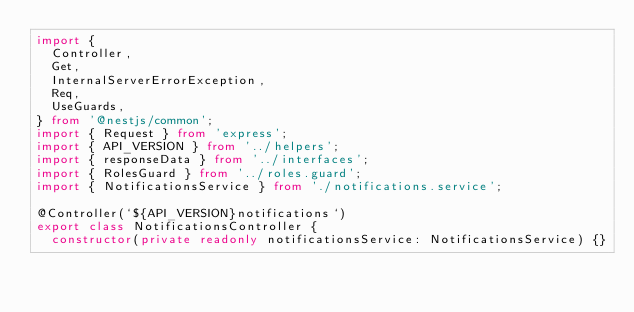<code> <loc_0><loc_0><loc_500><loc_500><_TypeScript_>import {
  Controller,
  Get,
  InternalServerErrorException,
  Req,
  UseGuards,
} from '@nestjs/common';
import { Request } from 'express';
import { API_VERSION } from '../helpers';
import { responseData } from '../interfaces';
import { RolesGuard } from '../roles.guard';
import { NotificationsService } from './notifications.service';

@Controller(`${API_VERSION}notifications`)
export class NotificationsController {
  constructor(private readonly notificationsService: NotificationsService) {}
</code> 